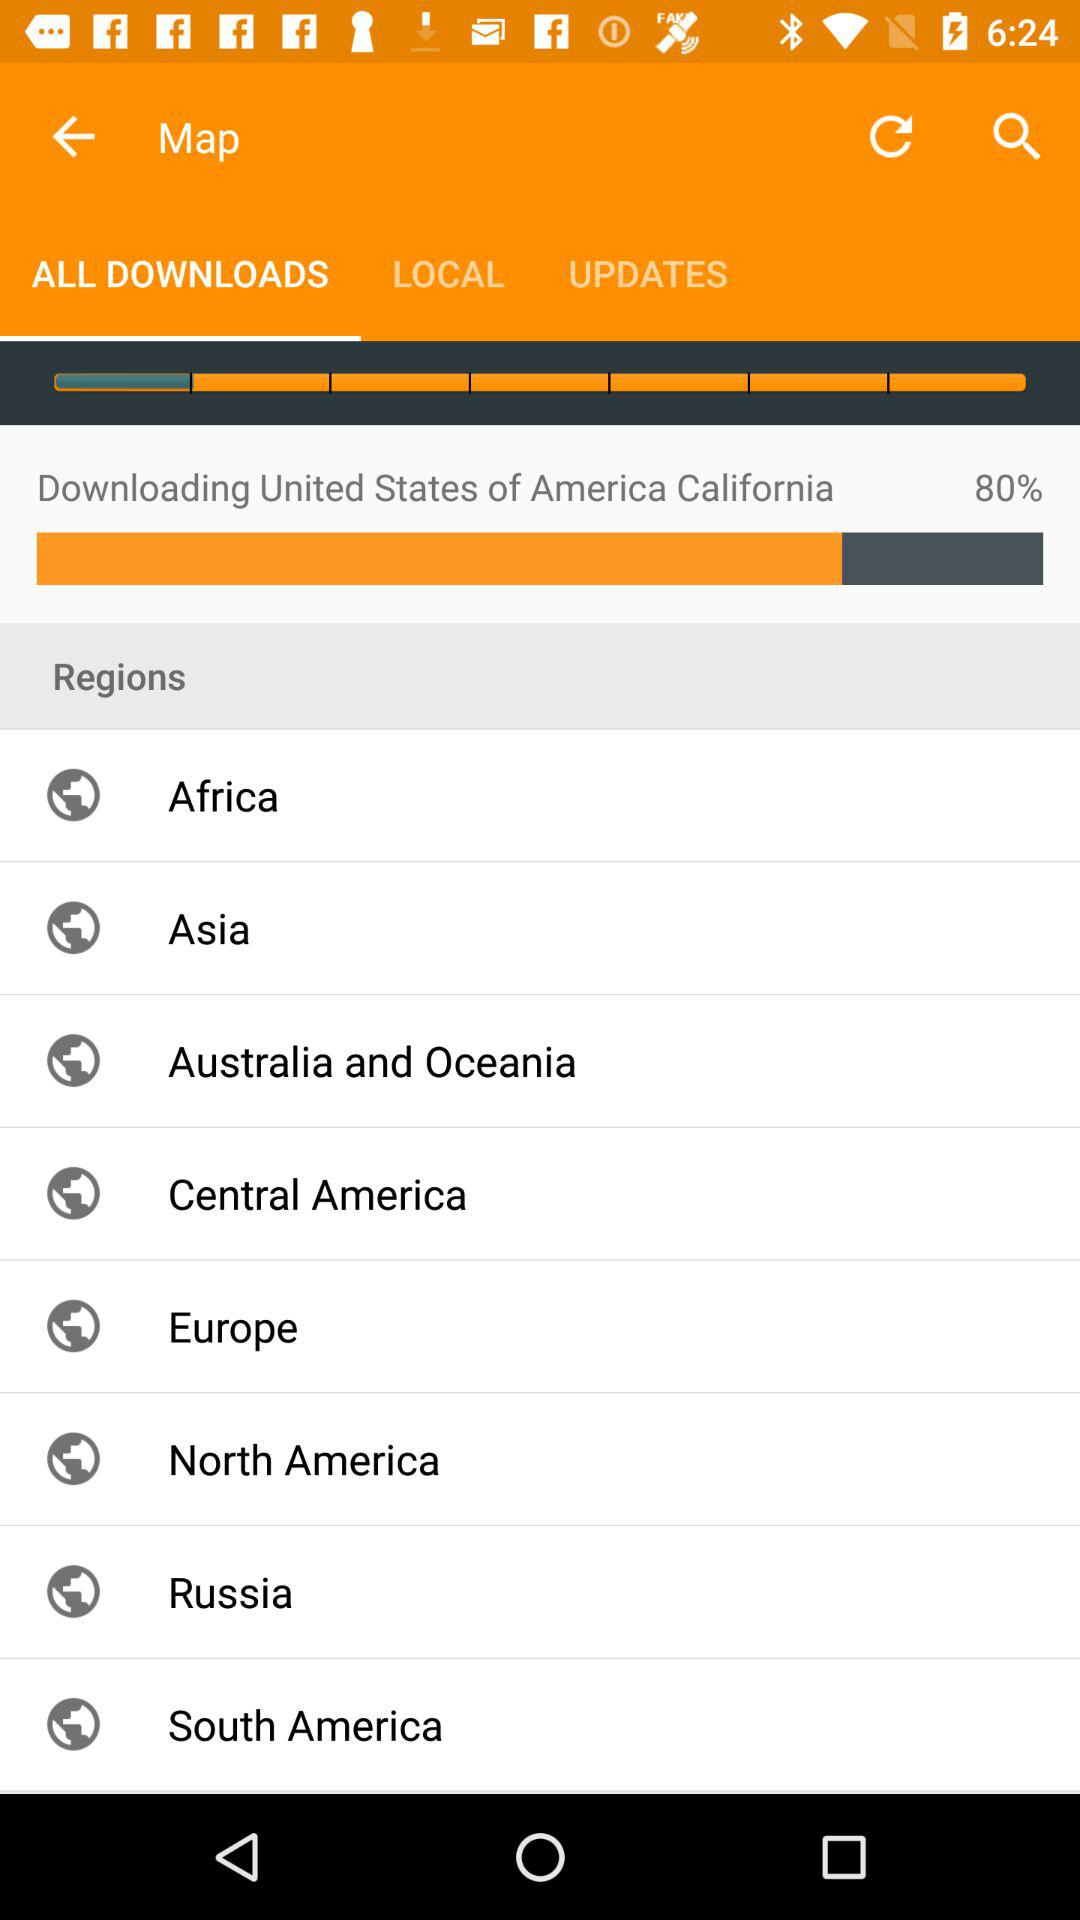Which option is selected for "Map"? The selected option is "ALL DOWNLOADS". 